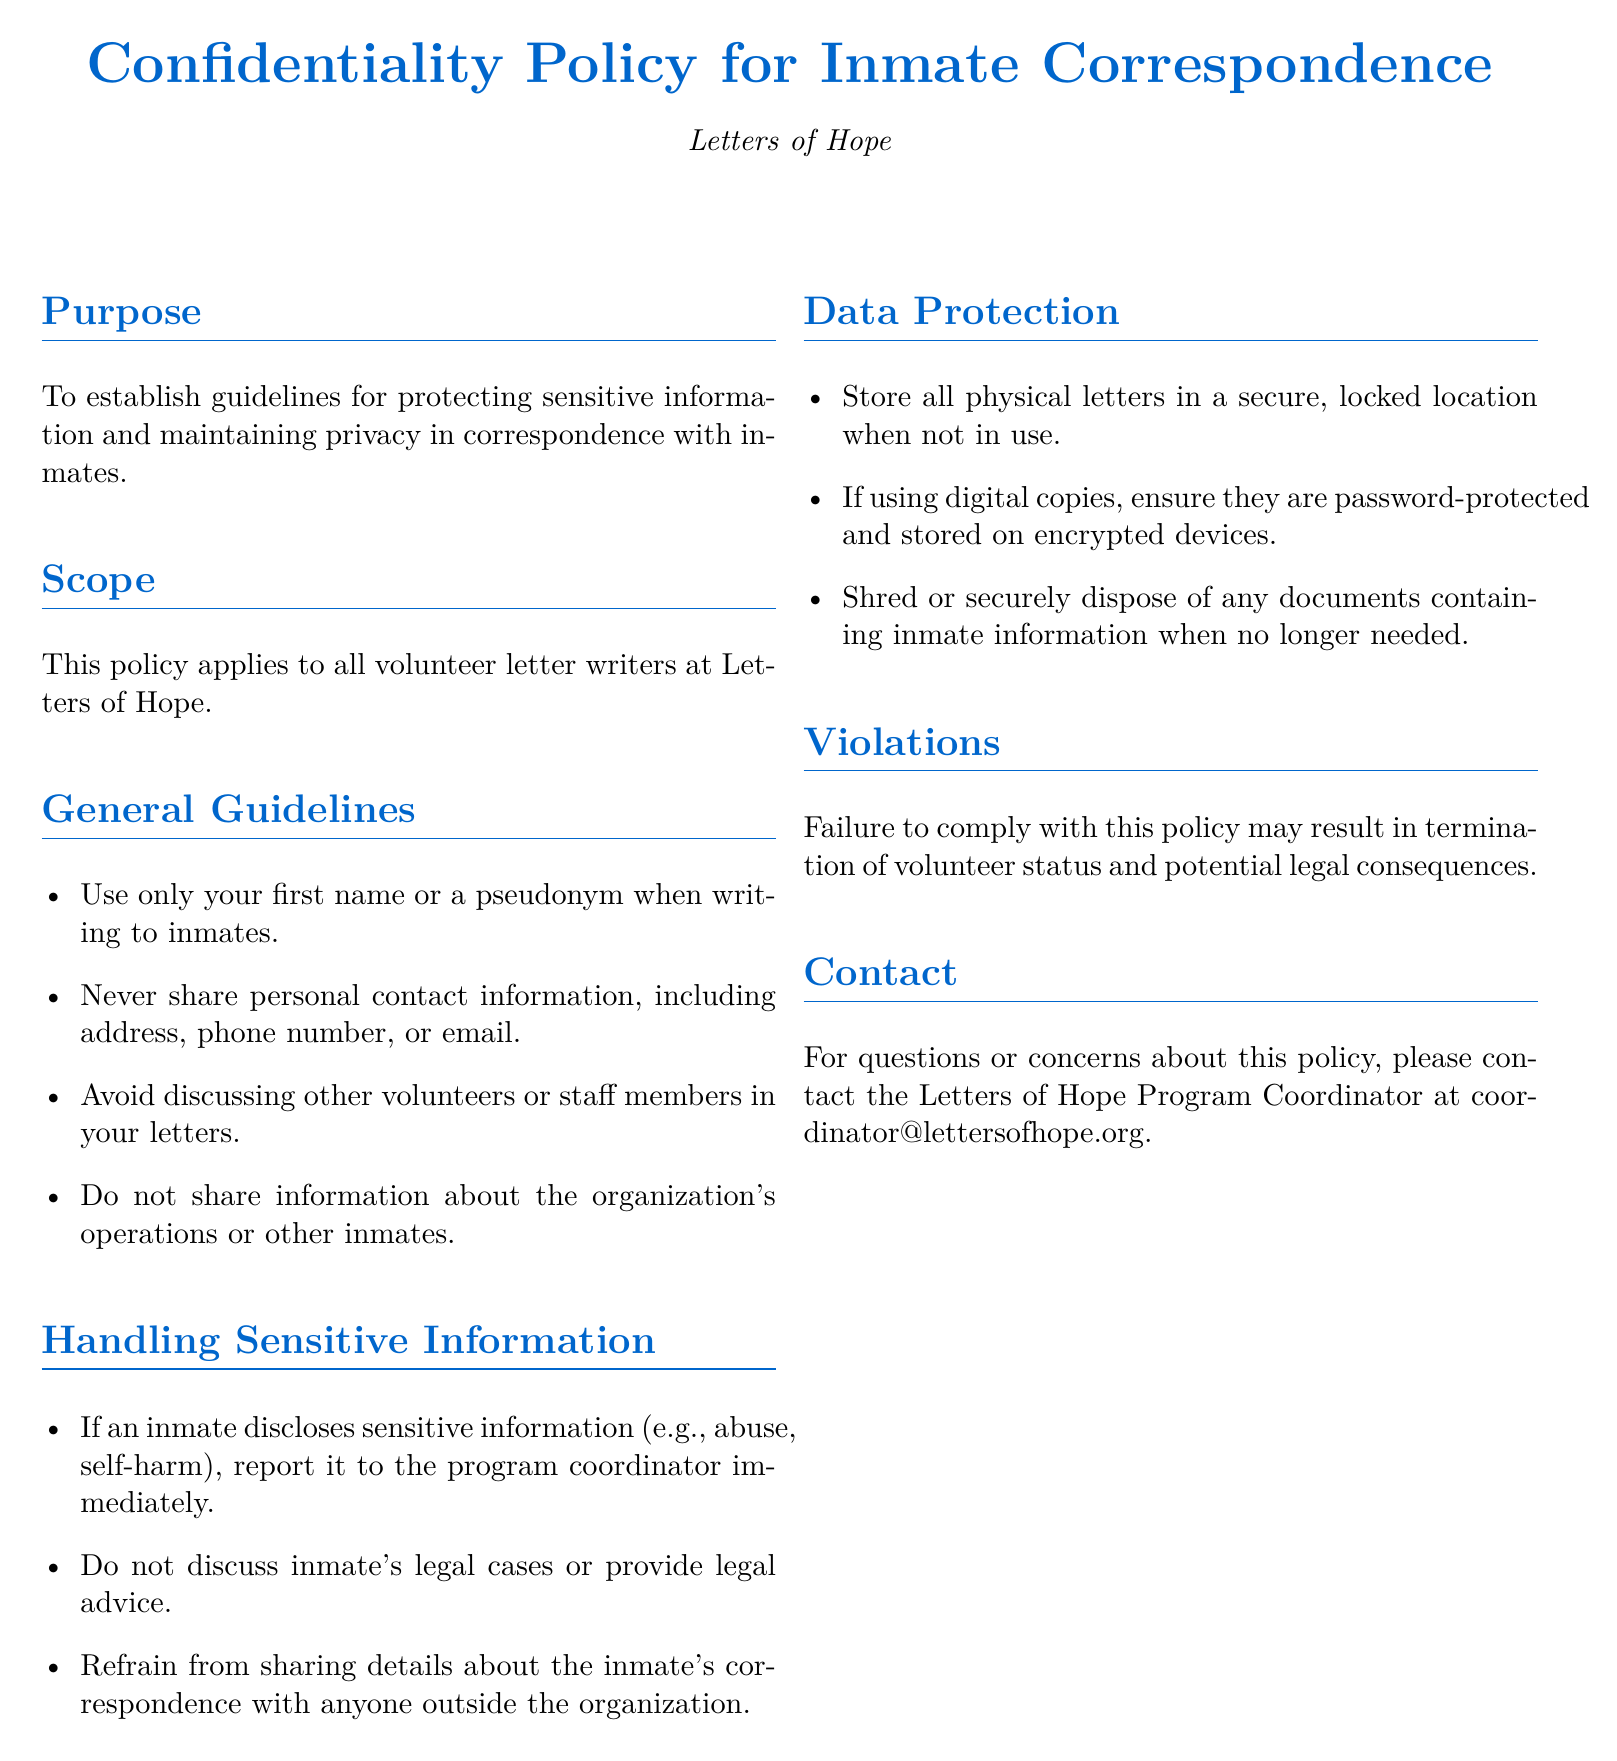what is the purpose of the policy? The purpose of the policy is to establish guidelines for protecting sensitive information and maintaining privacy in correspondence with inmates.
Answer: to establish guidelines for protecting sensitive information and maintaining privacy who does the policy apply to? The policy applies to all volunteer letter writers at Letters of Hope.
Answer: all volunteer letter writers at Letters of Hope what should you use when writing to inmates? The guidelines state that you should use only your first name or a pseudonym when writing to inmates.
Answer: your first name or a pseudonym what should you do if an inmate discloses sensitive information? You should report it to the program coordinator immediately.
Answer: report it to the program coordinator immediately where should physical letters be stored? Physical letters should be stored in a secure, locked location when not in use.
Answer: a secure, locked location what might happen if you violate the policy? Failure to comply with this policy may result in termination of volunteer status and potential legal consequences.
Answer: termination of volunteer status and potential legal consequences who should you contact for questions or concerns about the policy? You should contact the Letters of Hope Program Coordinator at coordinator@lettersofhope.org.
Answer: the Letters of Hope Program Coordinator at coordinator@lettersofhope.org 